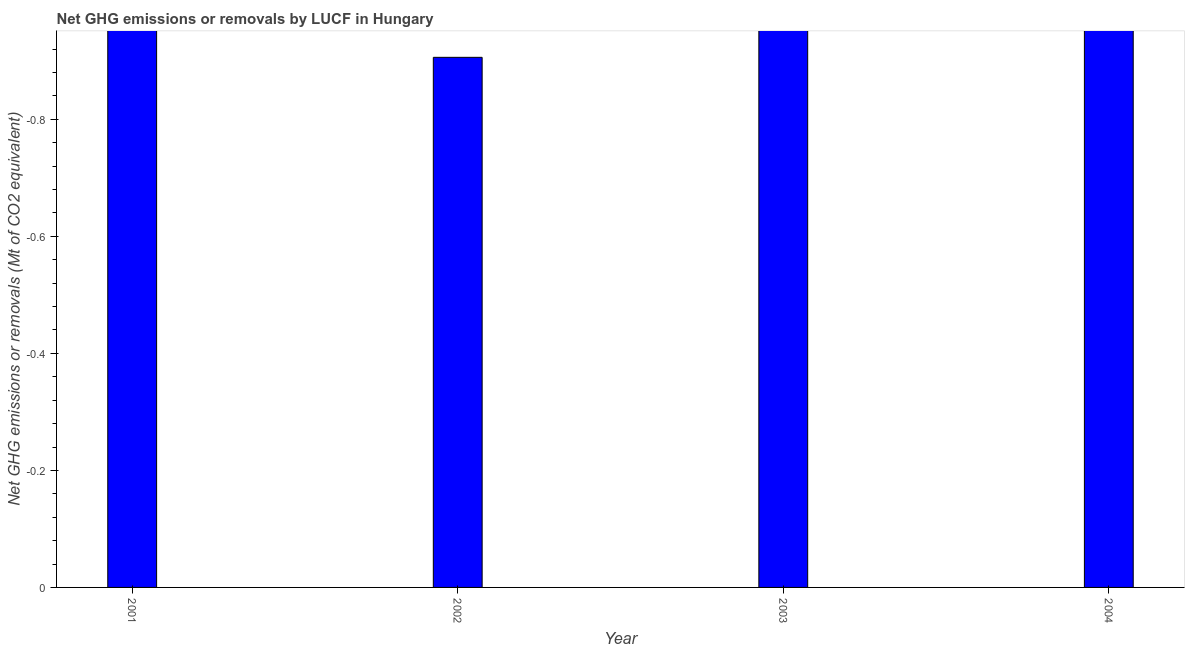What is the title of the graph?
Provide a short and direct response. Net GHG emissions or removals by LUCF in Hungary. What is the label or title of the X-axis?
Your answer should be very brief. Year. What is the label or title of the Y-axis?
Offer a very short reply. Net GHG emissions or removals (Mt of CO2 equivalent). What is the ghg net emissions or removals in 2003?
Make the answer very short. 0. Across all years, what is the minimum ghg net emissions or removals?
Provide a succinct answer. 0. What is the sum of the ghg net emissions or removals?
Ensure brevity in your answer.  0. What is the average ghg net emissions or removals per year?
Your response must be concise. 0. What is the median ghg net emissions or removals?
Offer a terse response. 0. In how many years, is the ghg net emissions or removals greater than -0.6 Mt?
Keep it short and to the point. 0. How many bars are there?
Your answer should be compact. 0. What is the difference between two consecutive major ticks on the Y-axis?
Give a very brief answer. 0.2. Are the values on the major ticks of Y-axis written in scientific E-notation?
Offer a terse response. No. What is the Net GHG emissions or removals (Mt of CO2 equivalent) in 2001?
Your response must be concise. 0. What is the Net GHG emissions or removals (Mt of CO2 equivalent) of 2003?
Ensure brevity in your answer.  0. 